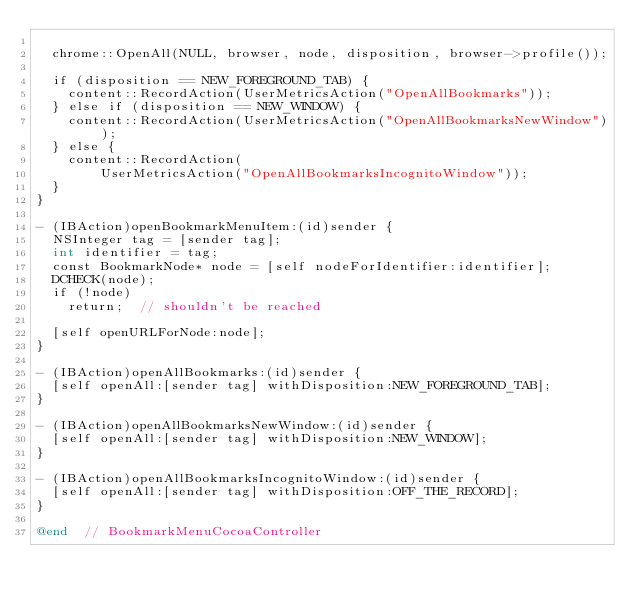Convert code to text. <code><loc_0><loc_0><loc_500><loc_500><_ObjectiveC_>
  chrome::OpenAll(NULL, browser, node, disposition, browser->profile());

  if (disposition == NEW_FOREGROUND_TAB) {
    content::RecordAction(UserMetricsAction("OpenAllBookmarks"));
  } else if (disposition == NEW_WINDOW) {
    content::RecordAction(UserMetricsAction("OpenAllBookmarksNewWindow"));
  } else {
    content::RecordAction(
        UserMetricsAction("OpenAllBookmarksIncognitoWindow"));
  }
}

- (IBAction)openBookmarkMenuItem:(id)sender {
  NSInteger tag = [sender tag];
  int identifier = tag;
  const BookmarkNode* node = [self nodeForIdentifier:identifier];
  DCHECK(node);
  if (!node)
    return;  // shouldn't be reached

  [self openURLForNode:node];
}

- (IBAction)openAllBookmarks:(id)sender {
  [self openAll:[sender tag] withDisposition:NEW_FOREGROUND_TAB];
}

- (IBAction)openAllBookmarksNewWindow:(id)sender {
  [self openAll:[sender tag] withDisposition:NEW_WINDOW];
}

- (IBAction)openAllBookmarksIncognitoWindow:(id)sender {
  [self openAll:[sender tag] withDisposition:OFF_THE_RECORD];
}

@end  // BookmarkMenuCocoaController
</code> 